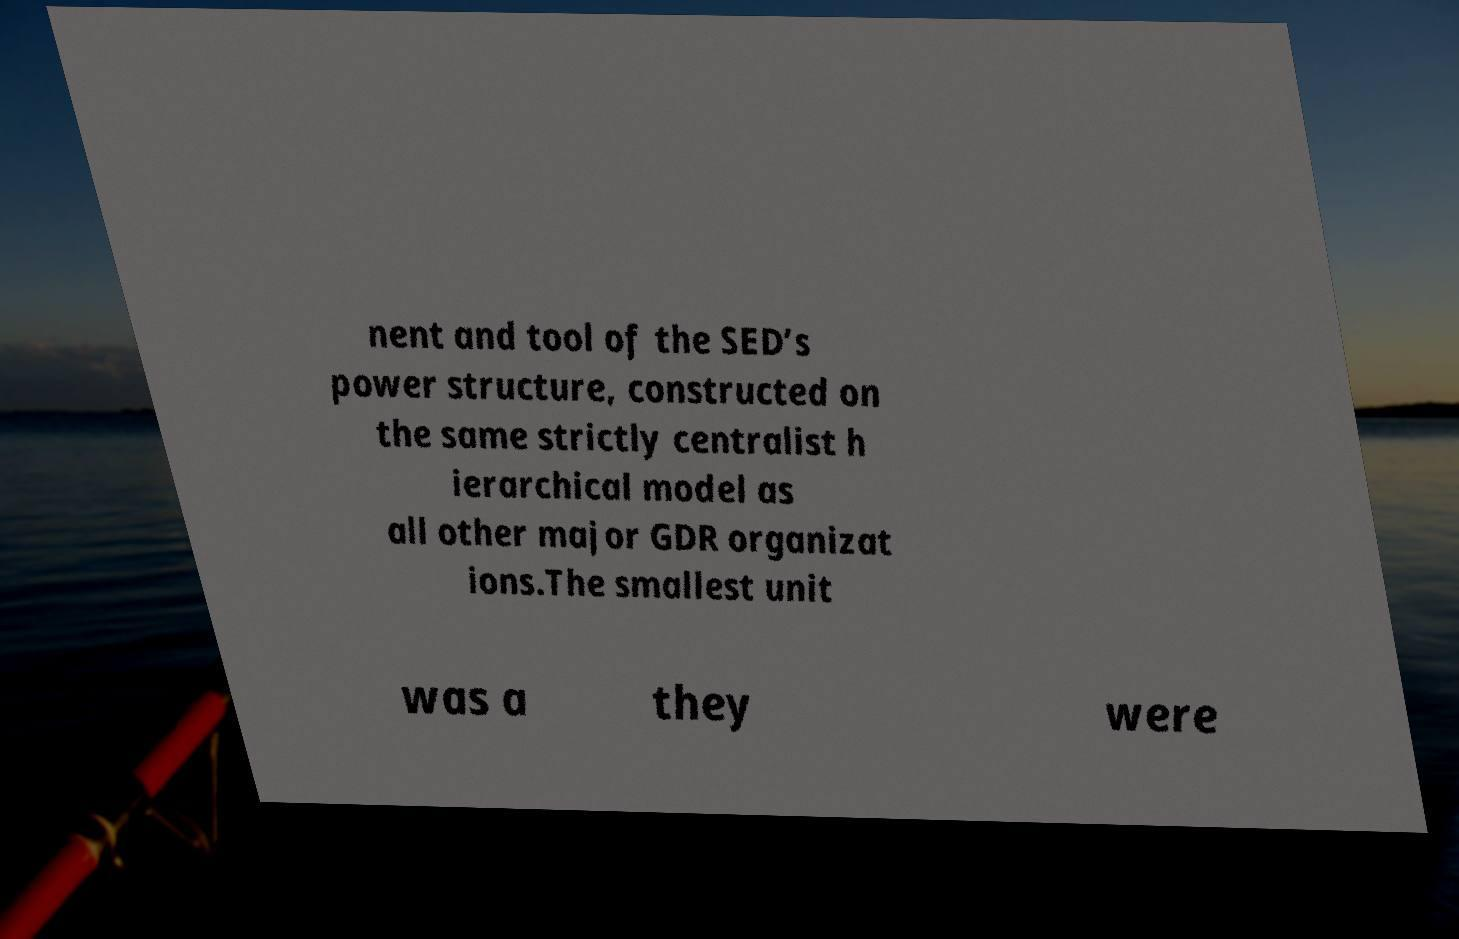Please read and relay the text visible in this image. What does it say? nent and tool of the SED’s power structure, constructed on the same strictly centralist h ierarchical model as all other major GDR organizat ions.The smallest unit was a they were 